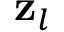<formula> <loc_0><loc_0><loc_500><loc_500>z _ { l }</formula> 